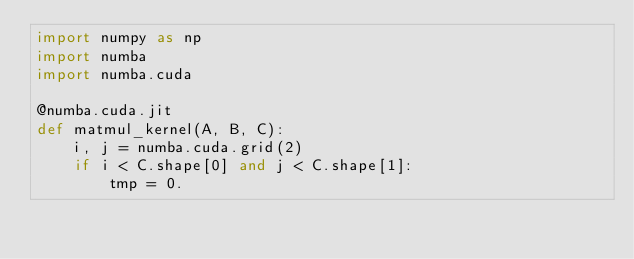Convert code to text. <code><loc_0><loc_0><loc_500><loc_500><_Python_>import numpy as np
import numba
import numba.cuda

@numba.cuda.jit
def matmul_kernel(A, B, C):
    i, j = numba.cuda.grid(2)
    if i < C.shape[0] and j < C.shape[1]:
        tmp = 0.</code> 